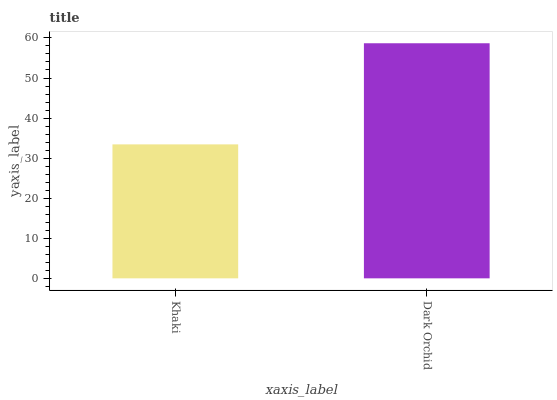Is Dark Orchid the minimum?
Answer yes or no. No. Is Dark Orchid greater than Khaki?
Answer yes or no. Yes. Is Khaki less than Dark Orchid?
Answer yes or no. Yes. Is Khaki greater than Dark Orchid?
Answer yes or no. No. Is Dark Orchid less than Khaki?
Answer yes or no. No. Is Dark Orchid the high median?
Answer yes or no. Yes. Is Khaki the low median?
Answer yes or no. Yes. Is Khaki the high median?
Answer yes or no. No. Is Dark Orchid the low median?
Answer yes or no. No. 